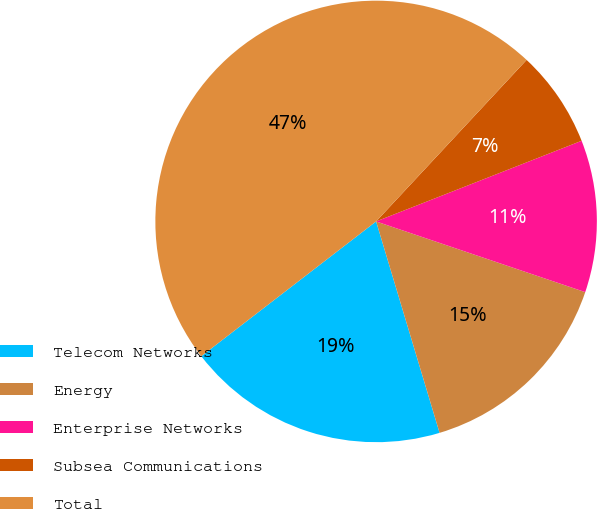Convert chart. <chart><loc_0><loc_0><loc_500><loc_500><pie_chart><fcel>Telecom Networks<fcel>Energy<fcel>Enterprise Networks<fcel>Subsea Communications<fcel>Total<nl><fcel>19.19%<fcel>15.17%<fcel>11.14%<fcel>7.11%<fcel>47.39%<nl></chart> 